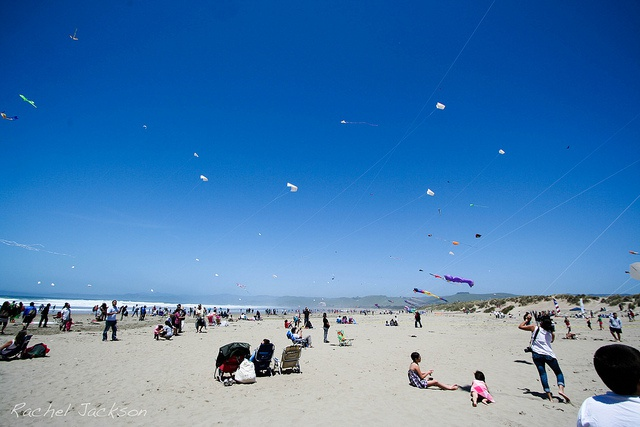Describe the objects in this image and their specific colors. I can see people in navy, black, darkgray, lavender, and gray tones, kite in navy, lightblue, blue, and gray tones, people in navy, black, lavender, and gray tones, people in navy, black, lightgray, lightpink, and maroon tones, and people in navy, lightgray, black, and lightpink tones in this image. 